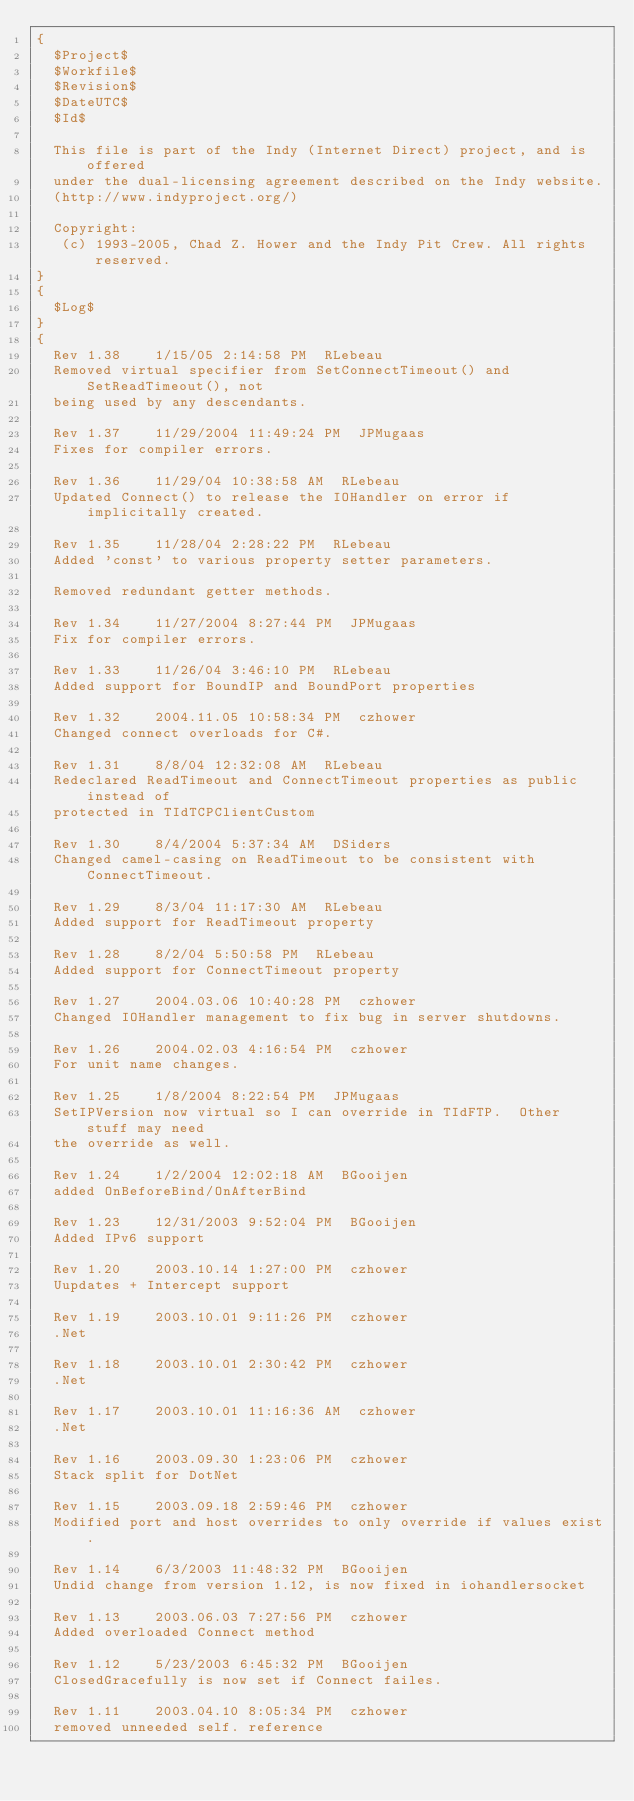Convert code to text. <code><loc_0><loc_0><loc_500><loc_500><_Pascal_>{
  $Project$
  $Workfile$
  $Revision$
  $DateUTC$
  $Id$

  This file is part of the Indy (Internet Direct) project, and is offered
  under the dual-licensing agreement described on the Indy website.
  (http://www.indyproject.org/)

  Copyright:
   (c) 1993-2005, Chad Z. Hower and the Indy Pit Crew. All rights reserved.
}
{
  $Log$
}
{
  Rev 1.38    1/15/05 2:14:58 PM  RLebeau
  Removed virtual specifier from SetConnectTimeout() and SetReadTimeout(), not
  being used by any descendants.

  Rev 1.37    11/29/2004 11:49:24 PM  JPMugaas
  Fixes for compiler errors.

  Rev 1.36    11/29/04 10:38:58 AM  RLebeau
  Updated Connect() to release the IOHandler on error if implicitally created.

  Rev 1.35    11/28/04 2:28:22 PM  RLebeau
  Added 'const' to various property setter parameters.

  Removed redundant getter methods.

  Rev 1.34    11/27/2004 8:27:44 PM  JPMugaas
  Fix for compiler errors.

  Rev 1.33    11/26/04 3:46:10 PM  RLebeau
  Added support for BoundIP and BoundPort properties

  Rev 1.32    2004.11.05 10:58:34 PM  czhower
  Changed connect overloads for C#.

  Rev 1.31    8/8/04 12:32:08 AM  RLebeau
  Redeclared ReadTimeout and ConnectTimeout properties as public instead of
  protected in TIdTCPClientCustom

  Rev 1.30    8/4/2004 5:37:34 AM  DSiders
  Changed camel-casing on ReadTimeout to be consistent with ConnectTimeout.

  Rev 1.29    8/3/04 11:17:30 AM  RLebeau
  Added support for ReadTimeout property

  Rev 1.28    8/2/04 5:50:58 PM  RLebeau
  Added support for ConnectTimeout property

  Rev 1.27    2004.03.06 10:40:28 PM  czhower
  Changed IOHandler management to fix bug in server shutdowns.

  Rev 1.26    2004.02.03 4:16:54 PM  czhower
  For unit name changes.

  Rev 1.25    1/8/2004 8:22:54 PM  JPMugaas
  SetIPVersion now virtual so I can override in TIdFTP.  Other stuff may need
  the override as well.

  Rev 1.24    1/2/2004 12:02:18 AM  BGooijen
  added OnBeforeBind/OnAfterBind

  Rev 1.23    12/31/2003 9:52:04 PM  BGooijen
  Added IPv6 support

  Rev 1.20    2003.10.14 1:27:00 PM  czhower
  Uupdates + Intercept support

  Rev 1.19    2003.10.01 9:11:26 PM  czhower
  .Net

  Rev 1.18    2003.10.01 2:30:42 PM  czhower
  .Net

  Rev 1.17    2003.10.01 11:16:36 AM  czhower
  .Net

  Rev 1.16    2003.09.30 1:23:06 PM  czhower
  Stack split for DotNet

  Rev 1.15    2003.09.18 2:59:46 PM  czhower
  Modified port and host overrides to only override if values exist.

  Rev 1.14    6/3/2003 11:48:32 PM  BGooijen
  Undid change from version 1.12, is now fixed in iohandlersocket

  Rev 1.13    2003.06.03 7:27:56 PM  czhower
  Added overloaded Connect method

  Rev 1.12    5/23/2003 6:45:32 PM  BGooijen
  ClosedGracefully is now set if Connect failes.

  Rev 1.11    2003.04.10 8:05:34 PM  czhower
  removed unneeded self. reference
</code> 